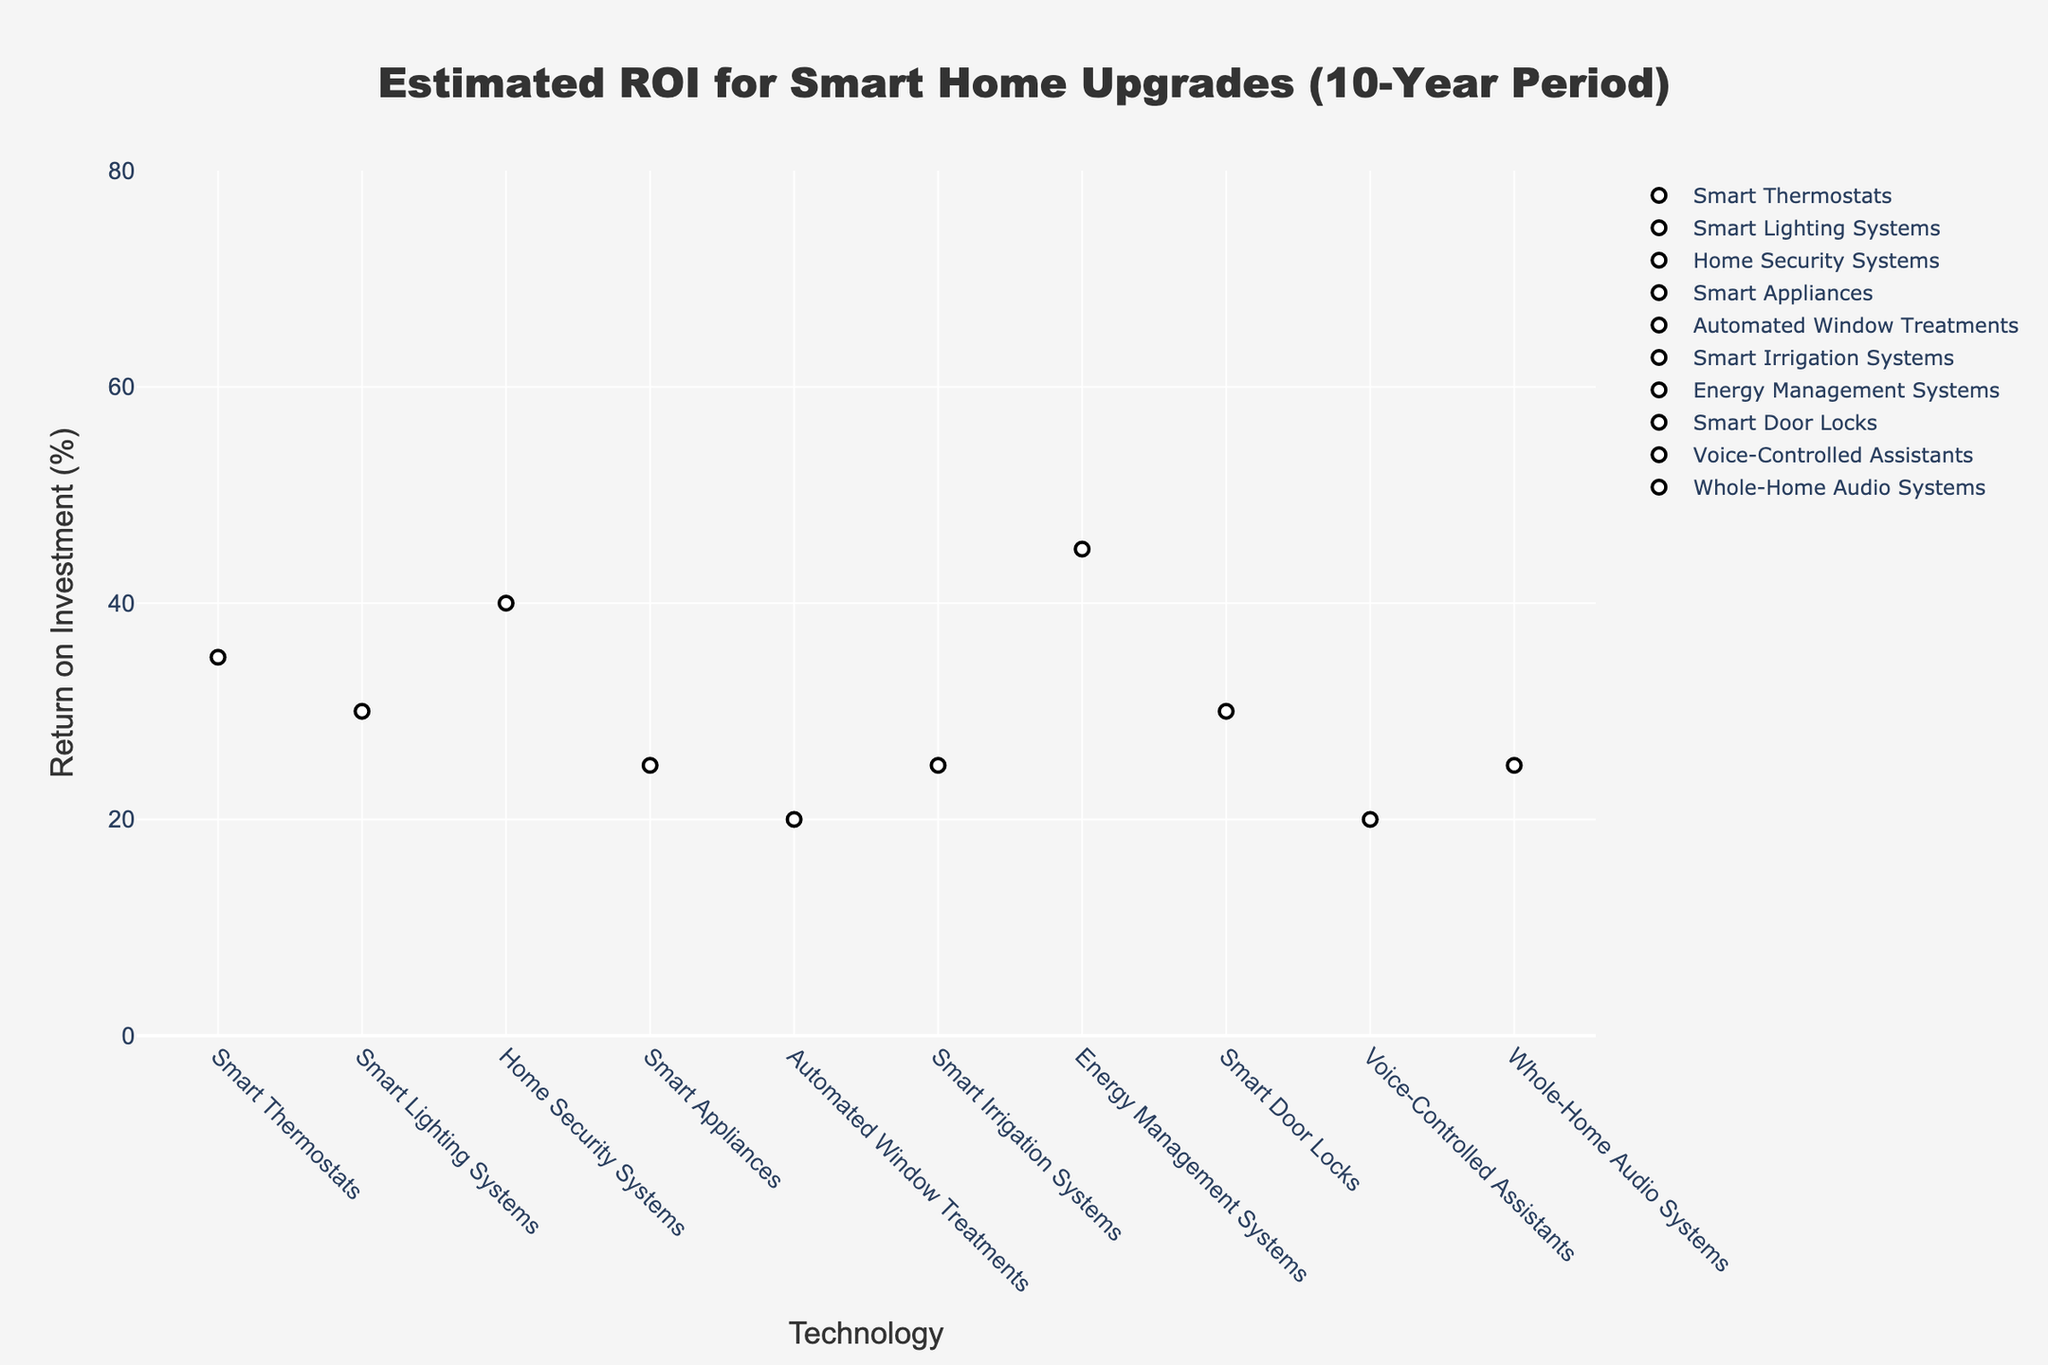What is the title of the figure? The title of the figure is displayed at the top center. It reads "Estimated ROI for Smart Home Upgrades (10-Year Period)", which indicates the scope of the analysis presented.
Answer: Estimated ROI for Smart Home Upgrades (10-Year Period) What does the y-axis represent? The y-axis of the figure is labeled "Return on Investment (%)", which indicates the percentage return on investment within a 10-year period for the various smart home upgrades being evaluated.
Answer: Return on Investment (%) Which technology has the highest median ROI? To determine the highest median ROI, locate the median ROI marker (white dots) across all technologies and identify the highest point. Energy Management Systems has the highest median ROI of 45%.
Answer: Energy Management Systems What is the median ROI for Smart Lighting Systems? The median ROI can be found by looking for the white marker dot on the plot corresponding to Smart Lighting Systems. The median ROI for Smart Lighting Systems is 30%.
Answer: 30% How does the median ROI of Smart Thermostats compare to Home Security Systems? Compare the median ROI marker (white dots) of both technologies. Smart Thermostats have a median ROI of 35%, while Home Security Systems have a median ROI of 40%. Therefore, Home Security Systems have a higher median ROI.
Answer: Home Security Systems has a higher median ROI Which technology has the widest range of ROI values? The range is calculated as the difference between the Max ROI and Min ROI. Identify the technology with the largest difference: Home Security Systems have the widest range from 20% to 70%, which is a range of 50%.
Answer: Home Security Systems What is the difference between the Median ROI of Smart Appliances and Smart Irrigation Systems? Locate the median ROI markers for both Smart Appliances and Smart Irrigation Systems, which are both at 25%. The difference between their median ROIs is 0%.
Answer: 0% Which technology has the lowest Min ROI? Identify the lowest point on the Min ROI scale for each technology. Both Automated Window Treatments and Voice-Controlled Assistants have the lowest Min ROI of 0%.
Answer: Automated Window Treatments and Voice-Controlled Assistants Which three technologies have the highest Max ROI? Sort the technologies based on their Max ROI values. The top three are Energy Management Systems (75%), Home Security Systems (70%), and Smart Thermostats (60%).
Answer: Energy Management Systems, Home Security Systems, Smart Thermostats Among Automated Window Treatments and Whole-Home Audio Systems, which has the higher High ROI? Locate the High ROI markers for both technologies. Automated Window Treatments have a High ROI of 30%, whereas Whole-Home Audio Systems have a High ROI of 35%. Whole-Home Audio Systems have a higher High ROI.
Answer: Whole-Home Audio Systems 